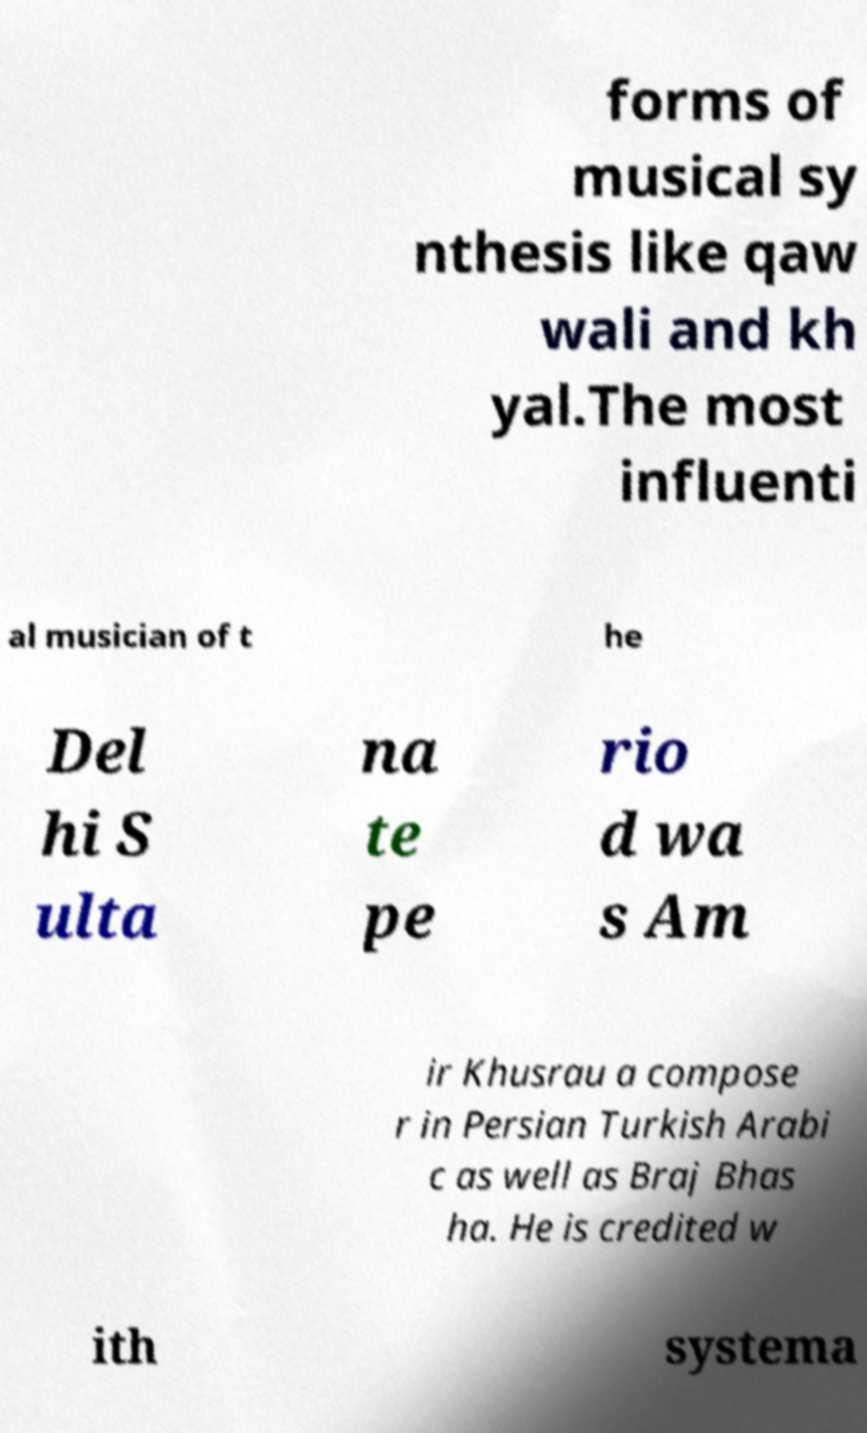Please identify and transcribe the text found in this image. forms of musical sy nthesis like qaw wali and kh yal.The most influenti al musician of t he Del hi S ulta na te pe rio d wa s Am ir Khusrau a compose r in Persian Turkish Arabi c as well as Braj Bhas ha. He is credited w ith systema 